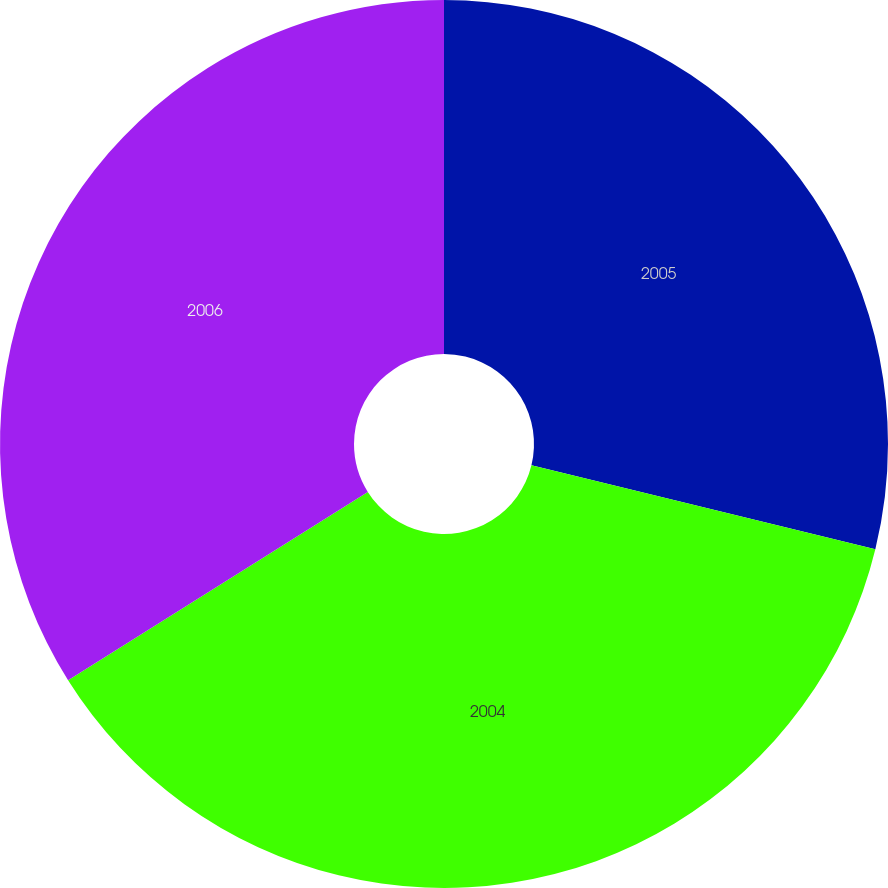<chart> <loc_0><loc_0><loc_500><loc_500><pie_chart><fcel>2005<fcel>2004<fcel>2006<nl><fcel>28.81%<fcel>37.26%<fcel>33.93%<nl></chart> 